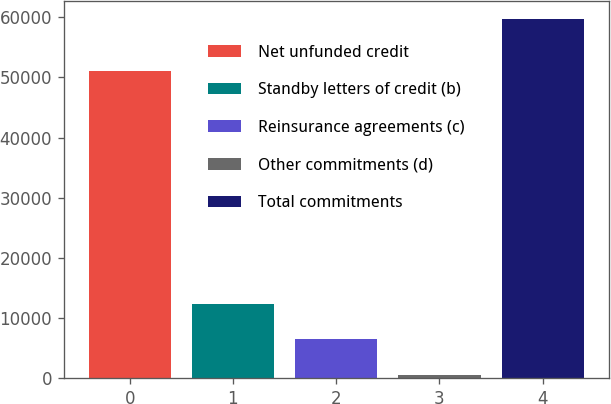Convert chart. <chart><loc_0><loc_0><loc_500><loc_500><bar_chart><fcel>Net unfunded credit<fcel>Standby letters of credit (b)<fcel>Reinsurance agreements (c)<fcel>Other commitments (d)<fcel>Total commitments<nl><fcel>51017<fcel>12412.4<fcel>6507.2<fcel>602<fcel>59654<nl></chart> 